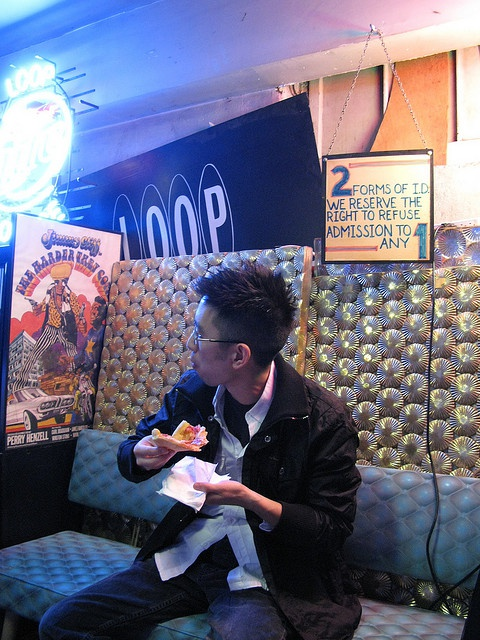Describe the objects in this image and their specific colors. I can see people in lightblue, black, navy, purple, and gray tones, bench in lightblue, black, blue, and gray tones, couch in lightblue, blue, gray, and navy tones, and pizza in lightblue, brown, tan, lightpink, and black tones in this image. 